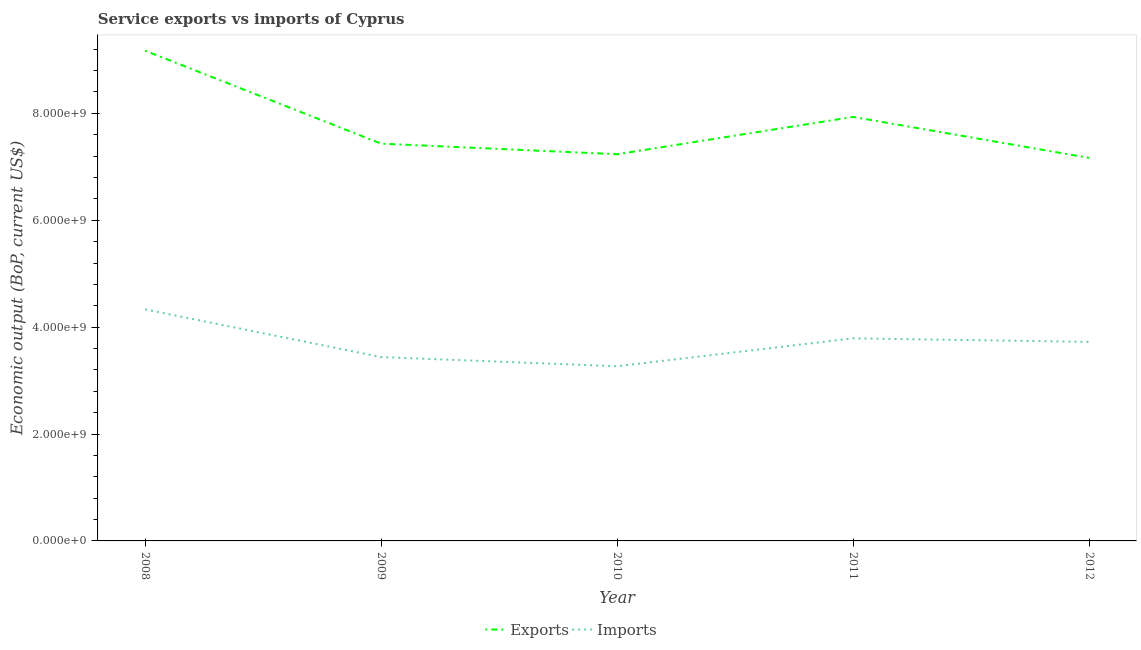Is the number of lines equal to the number of legend labels?
Offer a terse response. Yes. What is the amount of service exports in 2012?
Keep it short and to the point. 7.17e+09. Across all years, what is the maximum amount of service imports?
Keep it short and to the point. 4.33e+09. Across all years, what is the minimum amount of service exports?
Offer a terse response. 7.17e+09. In which year was the amount of service exports maximum?
Your response must be concise. 2008. What is the total amount of service exports in the graph?
Provide a succinct answer. 3.89e+1. What is the difference between the amount of service imports in 2008 and that in 2011?
Provide a short and direct response. 5.42e+08. What is the difference between the amount of service imports in 2012 and the amount of service exports in 2011?
Your response must be concise. -4.21e+09. What is the average amount of service exports per year?
Your response must be concise. 7.79e+09. In the year 2012, what is the difference between the amount of service exports and amount of service imports?
Give a very brief answer. 3.44e+09. What is the ratio of the amount of service imports in 2009 to that in 2011?
Make the answer very short. 0.91. What is the difference between the highest and the second highest amount of service imports?
Keep it short and to the point. 5.42e+08. What is the difference between the highest and the lowest amount of service imports?
Your response must be concise. 1.06e+09. Is the sum of the amount of service exports in 2009 and 2012 greater than the maximum amount of service imports across all years?
Your answer should be very brief. Yes. Is the amount of service exports strictly greater than the amount of service imports over the years?
Your answer should be compact. Yes. How many lines are there?
Offer a very short reply. 2. How many years are there in the graph?
Make the answer very short. 5. Are the values on the major ticks of Y-axis written in scientific E-notation?
Your answer should be very brief. Yes. Where does the legend appear in the graph?
Provide a succinct answer. Bottom center. What is the title of the graph?
Offer a terse response. Service exports vs imports of Cyprus. Does "Females" appear as one of the legend labels in the graph?
Make the answer very short. No. What is the label or title of the Y-axis?
Give a very brief answer. Economic output (BoP, current US$). What is the Economic output (BoP, current US$) in Exports in 2008?
Offer a terse response. 9.17e+09. What is the Economic output (BoP, current US$) of Imports in 2008?
Give a very brief answer. 4.33e+09. What is the Economic output (BoP, current US$) in Exports in 2009?
Ensure brevity in your answer.  7.43e+09. What is the Economic output (BoP, current US$) in Imports in 2009?
Your answer should be very brief. 3.44e+09. What is the Economic output (BoP, current US$) in Exports in 2010?
Your answer should be very brief. 7.24e+09. What is the Economic output (BoP, current US$) of Imports in 2010?
Provide a short and direct response. 3.27e+09. What is the Economic output (BoP, current US$) of Exports in 2011?
Your answer should be very brief. 7.93e+09. What is the Economic output (BoP, current US$) of Imports in 2011?
Give a very brief answer. 3.79e+09. What is the Economic output (BoP, current US$) in Exports in 2012?
Your answer should be compact. 7.17e+09. What is the Economic output (BoP, current US$) of Imports in 2012?
Your answer should be compact. 3.72e+09. Across all years, what is the maximum Economic output (BoP, current US$) of Exports?
Give a very brief answer. 9.17e+09. Across all years, what is the maximum Economic output (BoP, current US$) in Imports?
Make the answer very short. 4.33e+09. Across all years, what is the minimum Economic output (BoP, current US$) of Exports?
Your answer should be compact. 7.17e+09. Across all years, what is the minimum Economic output (BoP, current US$) of Imports?
Offer a very short reply. 3.27e+09. What is the total Economic output (BoP, current US$) in Exports in the graph?
Your answer should be very brief. 3.89e+1. What is the total Economic output (BoP, current US$) in Imports in the graph?
Your answer should be compact. 1.86e+1. What is the difference between the Economic output (BoP, current US$) in Exports in 2008 and that in 2009?
Offer a very short reply. 1.74e+09. What is the difference between the Economic output (BoP, current US$) of Imports in 2008 and that in 2009?
Ensure brevity in your answer.  8.92e+08. What is the difference between the Economic output (BoP, current US$) in Exports in 2008 and that in 2010?
Provide a short and direct response. 1.94e+09. What is the difference between the Economic output (BoP, current US$) of Imports in 2008 and that in 2010?
Your response must be concise. 1.06e+09. What is the difference between the Economic output (BoP, current US$) in Exports in 2008 and that in 2011?
Offer a very short reply. 1.24e+09. What is the difference between the Economic output (BoP, current US$) of Imports in 2008 and that in 2011?
Keep it short and to the point. 5.42e+08. What is the difference between the Economic output (BoP, current US$) in Exports in 2008 and that in 2012?
Ensure brevity in your answer.  2.01e+09. What is the difference between the Economic output (BoP, current US$) in Imports in 2008 and that in 2012?
Your answer should be very brief. 6.08e+08. What is the difference between the Economic output (BoP, current US$) in Exports in 2009 and that in 2010?
Provide a succinct answer. 1.98e+08. What is the difference between the Economic output (BoP, current US$) in Imports in 2009 and that in 2010?
Offer a terse response. 1.71e+08. What is the difference between the Economic output (BoP, current US$) of Exports in 2009 and that in 2011?
Make the answer very short. -5.00e+08. What is the difference between the Economic output (BoP, current US$) in Imports in 2009 and that in 2011?
Your response must be concise. -3.51e+08. What is the difference between the Economic output (BoP, current US$) of Exports in 2009 and that in 2012?
Your answer should be very brief. 2.67e+08. What is the difference between the Economic output (BoP, current US$) of Imports in 2009 and that in 2012?
Your response must be concise. -2.84e+08. What is the difference between the Economic output (BoP, current US$) of Exports in 2010 and that in 2011?
Keep it short and to the point. -6.98e+08. What is the difference between the Economic output (BoP, current US$) in Imports in 2010 and that in 2011?
Your answer should be compact. -5.22e+08. What is the difference between the Economic output (BoP, current US$) in Exports in 2010 and that in 2012?
Make the answer very short. 6.93e+07. What is the difference between the Economic output (BoP, current US$) of Imports in 2010 and that in 2012?
Ensure brevity in your answer.  -4.56e+08. What is the difference between the Economic output (BoP, current US$) of Exports in 2011 and that in 2012?
Offer a very short reply. 7.67e+08. What is the difference between the Economic output (BoP, current US$) of Imports in 2011 and that in 2012?
Keep it short and to the point. 6.62e+07. What is the difference between the Economic output (BoP, current US$) of Exports in 2008 and the Economic output (BoP, current US$) of Imports in 2009?
Offer a very short reply. 5.73e+09. What is the difference between the Economic output (BoP, current US$) in Exports in 2008 and the Economic output (BoP, current US$) in Imports in 2010?
Give a very brief answer. 5.90e+09. What is the difference between the Economic output (BoP, current US$) in Exports in 2008 and the Economic output (BoP, current US$) in Imports in 2011?
Your response must be concise. 5.38e+09. What is the difference between the Economic output (BoP, current US$) of Exports in 2008 and the Economic output (BoP, current US$) of Imports in 2012?
Make the answer very short. 5.45e+09. What is the difference between the Economic output (BoP, current US$) of Exports in 2009 and the Economic output (BoP, current US$) of Imports in 2010?
Make the answer very short. 4.16e+09. What is the difference between the Economic output (BoP, current US$) in Exports in 2009 and the Economic output (BoP, current US$) in Imports in 2011?
Give a very brief answer. 3.64e+09. What is the difference between the Economic output (BoP, current US$) in Exports in 2009 and the Economic output (BoP, current US$) in Imports in 2012?
Your answer should be very brief. 3.71e+09. What is the difference between the Economic output (BoP, current US$) in Exports in 2010 and the Economic output (BoP, current US$) in Imports in 2011?
Your response must be concise. 3.44e+09. What is the difference between the Economic output (BoP, current US$) of Exports in 2010 and the Economic output (BoP, current US$) of Imports in 2012?
Keep it short and to the point. 3.51e+09. What is the difference between the Economic output (BoP, current US$) in Exports in 2011 and the Economic output (BoP, current US$) in Imports in 2012?
Make the answer very short. 4.21e+09. What is the average Economic output (BoP, current US$) of Exports per year?
Provide a succinct answer. 7.79e+09. What is the average Economic output (BoP, current US$) of Imports per year?
Ensure brevity in your answer.  3.71e+09. In the year 2008, what is the difference between the Economic output (BoP, current US$) in Exports and Economic output (BoP, current US$) in Imports?
Keep it short and to the point. 4.84e+09. In the year 2009, what is the difference between the Economic output (BoP, current US$) of Exports and Economic output (BoP, current US$) of Imports?
Offer a very short reply. 3.99e+09. In the year 2010, what is the difference between the Economic output (BoP, current US$) of Exports and Economic output (BoP, current US$) of Imports?
Your answer should be very brief. 3.97e+09. In the year 2011, what is the difference between the Economic output (BoP, current US$) of Exports and Economic output (BoP, current US$) of Imports?
Offer a terse response. 4.14e+09. In the year 2012, what is the difference between the Economic output (BoP, current US$) in Exports and Economic output (BoP, current US$) in Imports?
Offer a very short reply. 3.44e+09. What is the ratio of the Economic output (BoP, current US$) of Exports in 2008 to that in 2009?
Ensure brevity in your answer.  1.23. What is the ratio of the Economic output (BoP, current US$) in Imports in 2008 to that in 2009?
Your response must be concise. 1.26. What is the ratio of the Economic output (BoP, current US$) in Exports in 2008 to that in 2010?
Make the answer very short. 1.27. What is the ratio of the Economic output (BoP, current US$) in Imports in 2008 to that in 2010?
Offer a terse response. 1.33. What is the ratio of the Economic output (BoP, current US$) of Exports in 2008 to that in 2011?
Offer a very short reply. 1.16. What is the ratio of the Economic output (BoP, current US$) of Imports in 2008 to that in 2011?
Give a very brief answer. 1.14. What is the ratio of the Economic output (BoP, current US$) of Exports in 2008 to that in 2012?
Give a very brief answer. 1.28. What is the ratio of the Economic output (BoP, current US$) in Imports in 2008 to that in 2012?
Your answer should be very brief. 1.16. What is the ratio of the Economic output (BoP, current US$) of Exports in 2009 to that in 2010?
Give a very brief answer. 1.03. What is the ratio of the Economic output (BoP, current US$) of Imports in 2009 to that in 2010?
Offer a terse response. 1.05. What is the ratio of the Economic output (BoP, current US$) of Exports in 2009 to that in 2011?
Keep it short and to the point. 0.94. What is the ratio of the Economic output (BoP, current US$) of Imports in 2009 to that in 2011?
Offer a terse response. 0.91. What is the ratio of the Economic output (BoP, current US$) of Exports in 2009 to that in 2012?
Offer a very short reply. 1.04. What is the ratio of the Economic output (BoP, current US$) of Imports in 2009 to that in 2012?
Provide a succinct answer. 0.92. What is the ratio of the Economic output (BoP, current US$) in Exports in 2010 to that in 2011?
Your response must be concise. 0.91. What is the ratio of the Economic output (BoP, current US$) in Imports in 2010 to that in 2011?
Provide a short and direct response. 0.86. What is the ratio of the Economic output (BoP, current US$) in Exports in 2010 to that in 2012?
Give a very brief answer. 1.01. What is the ratio of the Economic output (BoP, current US$) in Imports in 2010 to that in 2012?
Keep it short and to the point. 0.88. What is the ratio of the Economic output (BoP, current US$) of Exports in 2011 to that in 2012?
Give a very brief answer. 1.11. What is the ratio of the Economic output (BoP, current US$) in Imports in 2011 to that in 2012?
Your answer should be compact. 1.02. What is the difference between the highest and the second highest Economic output (BoP, current US$) in Exports?
Your answer should be compact. 1.24e+09. What is the difference between the highest and the second highest Economic output (BoP, current US$) of Imports?
Offer a terse response. 5.42e+08. What is the difference between the highest and the lowest Economic output (BoP, current US$) of Exports?
Provide a succinct answer. 2.01e+09. What is the difference between the highest and the lowest Economic output (BoP, current US$) in Imports?
Your response must be concise. 1.06e+09. 